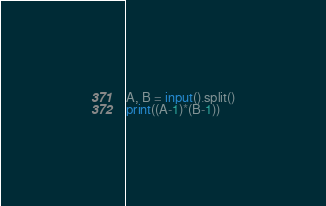Convert code to text. <code><loc_0><loc_0><loc_500><loc_500><_Python_>A, B = input().split()
print((A-1)*(B-1))</code> 